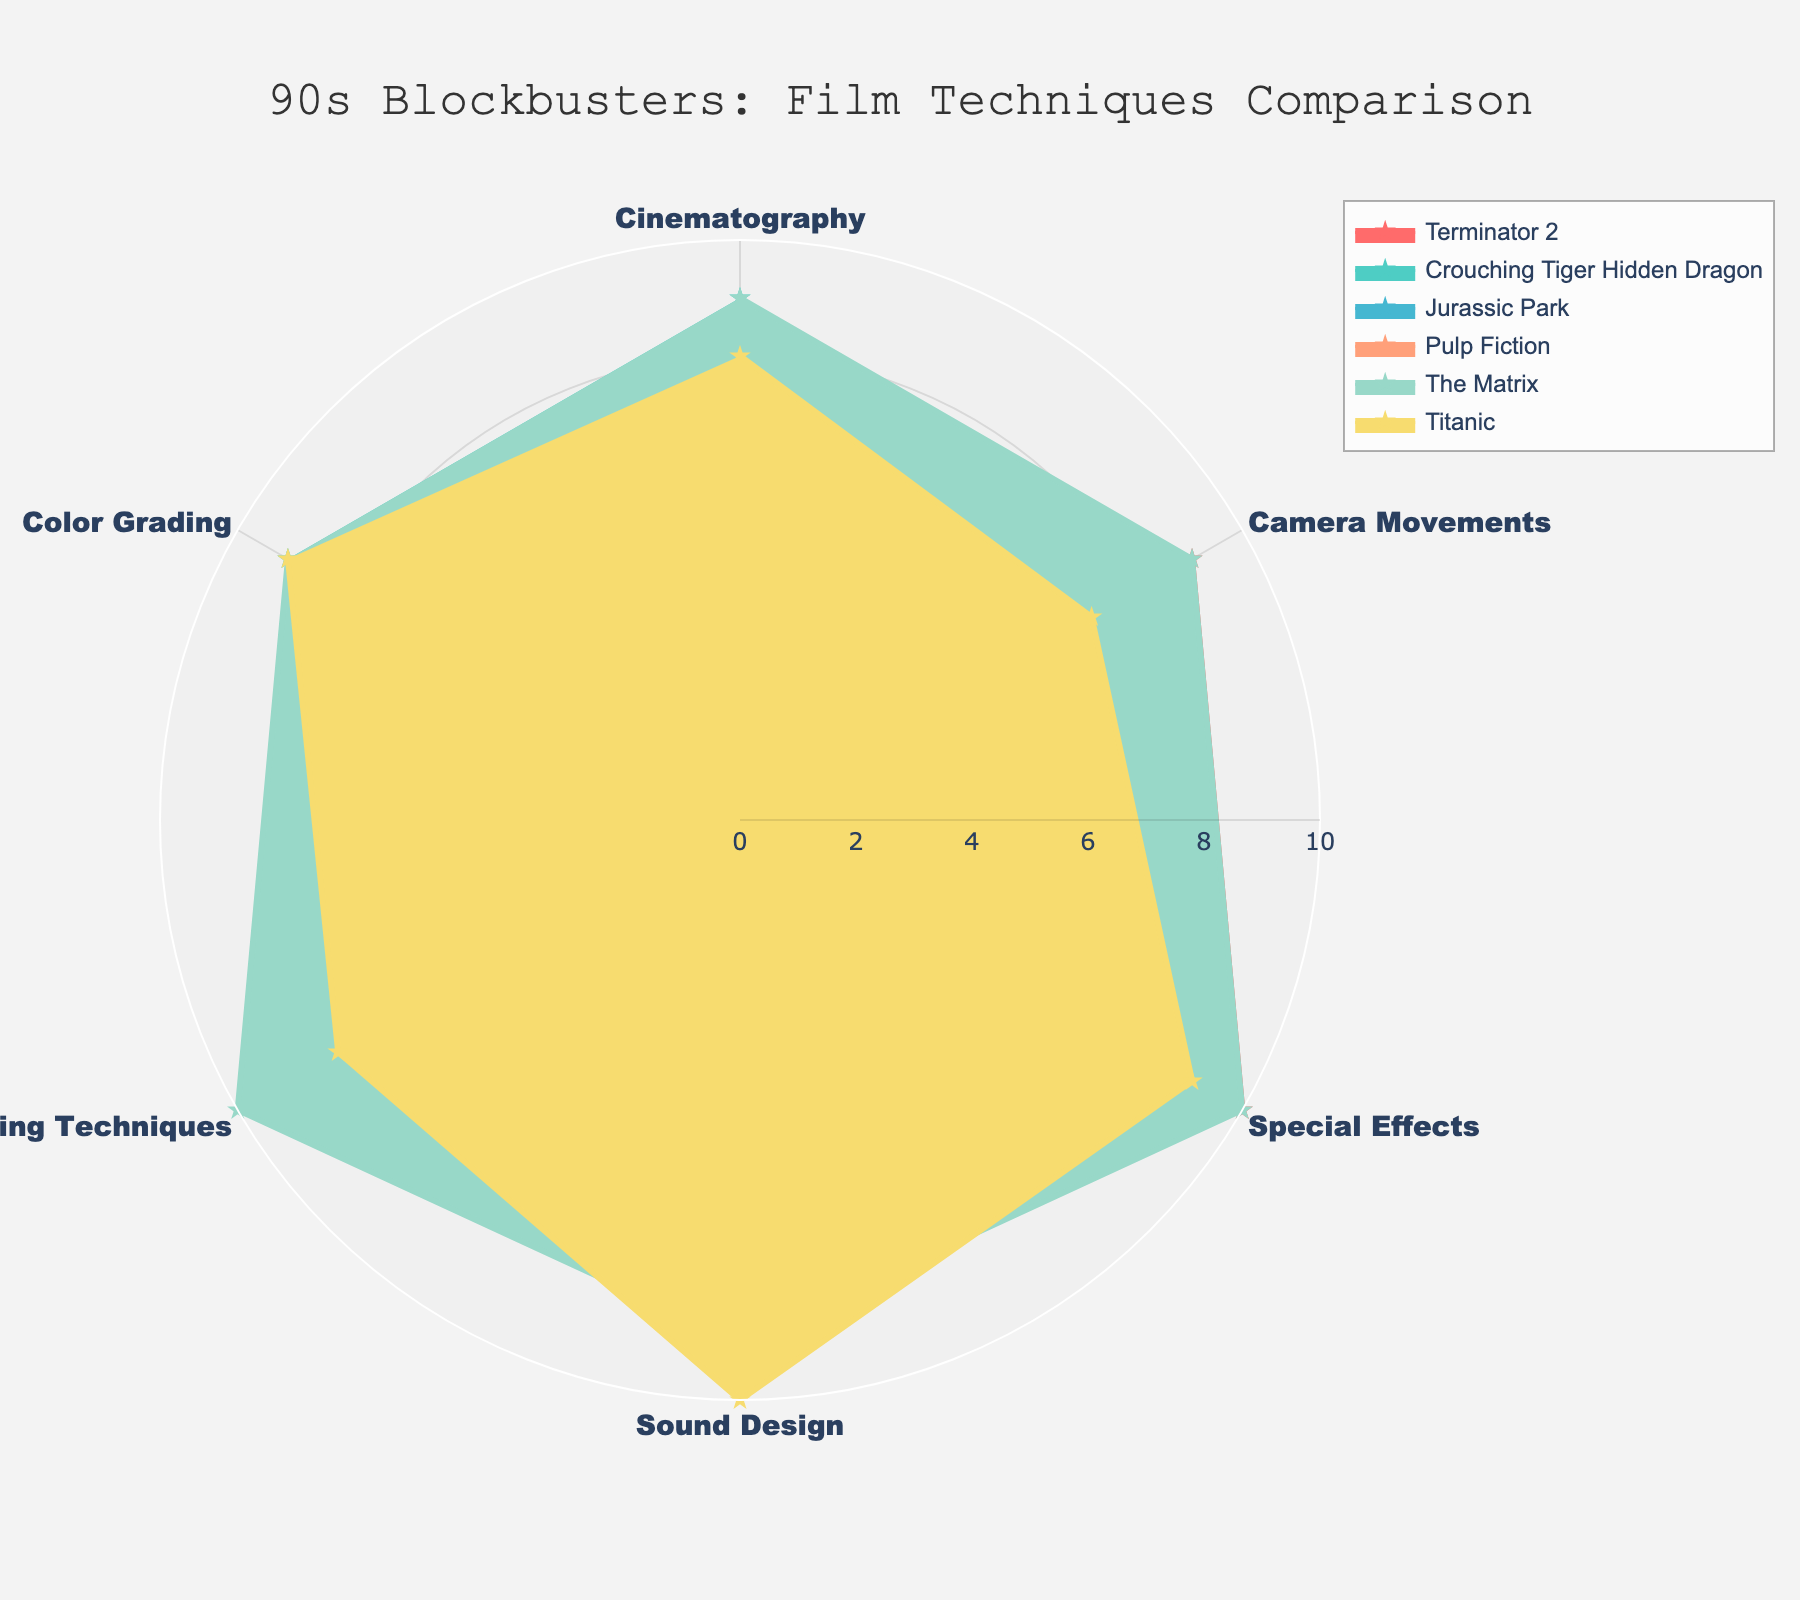What is the highest rating for Cinematography among the films? The cinematography ratings from the chart are: Terminator 2 - 8, Crouching Tiger Hidden Dragon - 9, Jurassic Park - 8, Pulp Fiction - 7, The Matrix - 9, Titanic - 8. The highest rating is 9 for Crouching Tiger Hidden Dragon and The Matrix.
Answer: 9 Which film has the highest special effects rating? The special effects ratings from the chart are: Terminator 2 - 10, Crouching Tiger Hidden Dragon - 7, Jurassic Park - 9, Pulp Fiction - 6, The Matrix - 10, Titanic - 9. The highest rating is shared by Terminator 2 and The Matrix, both with a rating of 10.
Answer: Terminator 2 and The Matrix What is the average Sound Design rating across all films? The sound design ratings from the chart are: Terminator 2 - 8, Crouching Tiger Hidden Dragon - 9, Jurassic Park - 9, Pulp Fiction - 8, The Matrix - 9, Titanic - 10. Summing these values gives 53, and there are 6 films, so the average rating is \( \frac{53}{6} \approx 8.83 \).
Answer: 8.83 Which film has the most balanced ratings across all techniques? A balanced rating would have all values close to each other. Terminator 2 has values (8, 9, 10, 8, 7, 8), indicating the highest variation is 3 (from 7 to 10). Checking other films' spreads: Crouching Tiger Hidden Dragon (9, 8, 7, 9, 8, 9) has a spread of 2, which is the lowest. Thus, Crouching Tiger Hidden Dragon is the most balanced.
Answer: Crouching Tiger Hidden Dragon How does the Camera Movements rating of Pulp Fiction compare to the other films? The camera movement ratings are: Terminator 2 - 9, Crouching Tiger Hidden Dragon - 8, Jurassic Park - 8, Pulp Fiction - 7, The Matrix - 9, Titanic - 7. Pulp Fiction's rating of 7 is lower than Terminator 2 and The Matrix, and equal to Titanic, but lower than Crouching Tiger Hidden Dragon and Jurassic Park.
Answer: Lower than most films, equal to Titanic What is the difference between the Special Effects ratings of Titanic and Jurassic Park? The special effects ratings from the chart are: Titanic - 9, Jurassic Park - 9. Thus, the difference between the ratings is \(9 - 9 = 0\).
Answer: 0 How many techniques does The Matrix score a perfect 10 in? The ratings for The Matrix are: Cinematography - 9, Camera Movements - 9, Special Effects - 10, Sound Design - 9, Editing Techniques - 10, Color Grading - 9. The Matrix scores a perfect 10 in Special Effects and Editing Techniques.
Answer: 2 